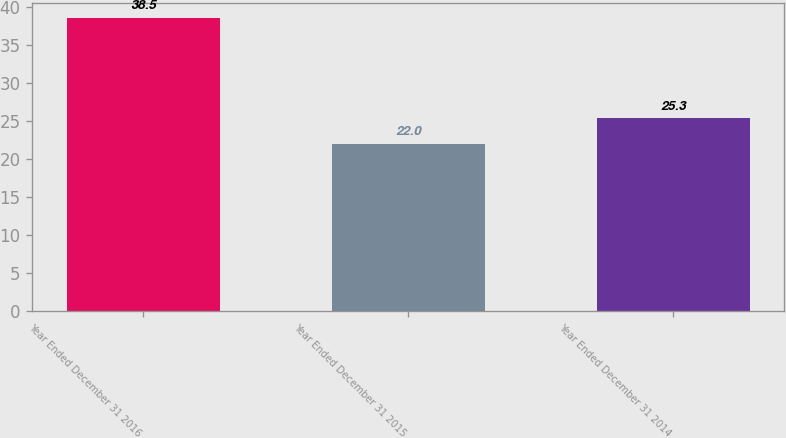Convert chart to OTSL. <chart><loc_0><loc_0><loc_500><loc_500><bar_chart><fcel>Year Ended December 31 2016<fcel>Year Ended December 31 2015<fcel>Year Ended December 31 2014<nl><fcel>38.5<fcel>22<fcel>25.3<nl></chart> 